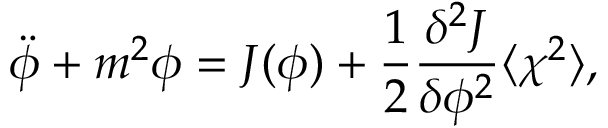Convert formula to latex. <formula><loc_0><loc_0><loc_500><loc_500>\ddot { \phi } + m ^ { 2 } { \phi } = J ( \phi ) + \frac { 1 } { 2 } \frac { { \delta } ^ { 2 } J } { { \delta } { \phi } ^ { 2 } } \langle { \chi } ^ { 2 } \rangle ,</formula> 